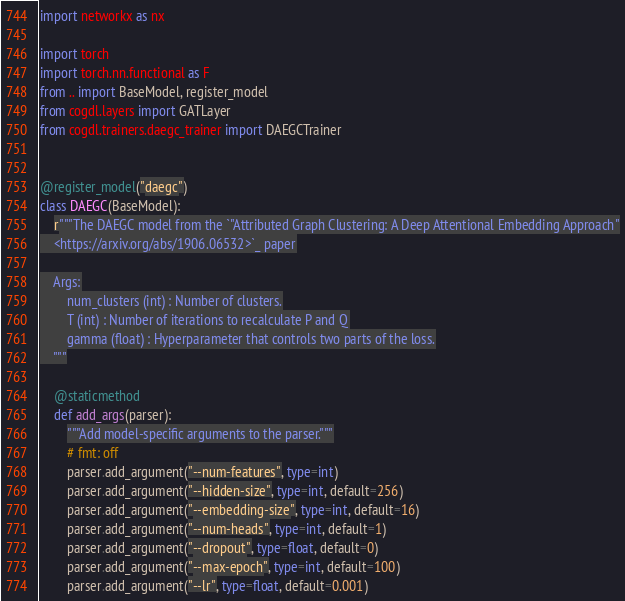Convert code to text. <code><loc_0><loc_0><loc_500><loc_500><_Python_>import networkx as nx

import torch
import torch.nn.functional as F
from .. import BaseModel, register_model
from cogdl.layers import GATLayer
from cogdl.trainers.daegc_trainer import DAEGCTrainer


@register_model("daegc")
class DAEGC(BaseModel):
    r"""The DAEGC model from the `"Attributed Graph Clustering: A Deep Attentional Embedding Approach"
    <https://arxiv.org/abs/1906.06532>`_ paper

    Args:
        num_clusters (int) : Number of clusters.
        T (int) : Number of iterations to recalculate P and Q
        gamma (float) : Hyperparameter that controls two parts of the loss.
    """

    @staticmethod
    def add_args(parser):
        """Add model-specific arguments to the parser."""
        # fmt: off
        parser.add_argument("--num-features", type=int)
        parser.add_argument("--hidden-size", type=int, default=256)
        parser.add_argument("--embedding-size", type=int, default=16)
        parser.add_argument("--num-heads", type=int, default=1)
        parser.add_argument("--dropout", type=float, default=0)
        parser.add_argument("--max-epoch", type=int, default=100)
        parser.add_argument("--lr", type=float, default=0.001)</code> 